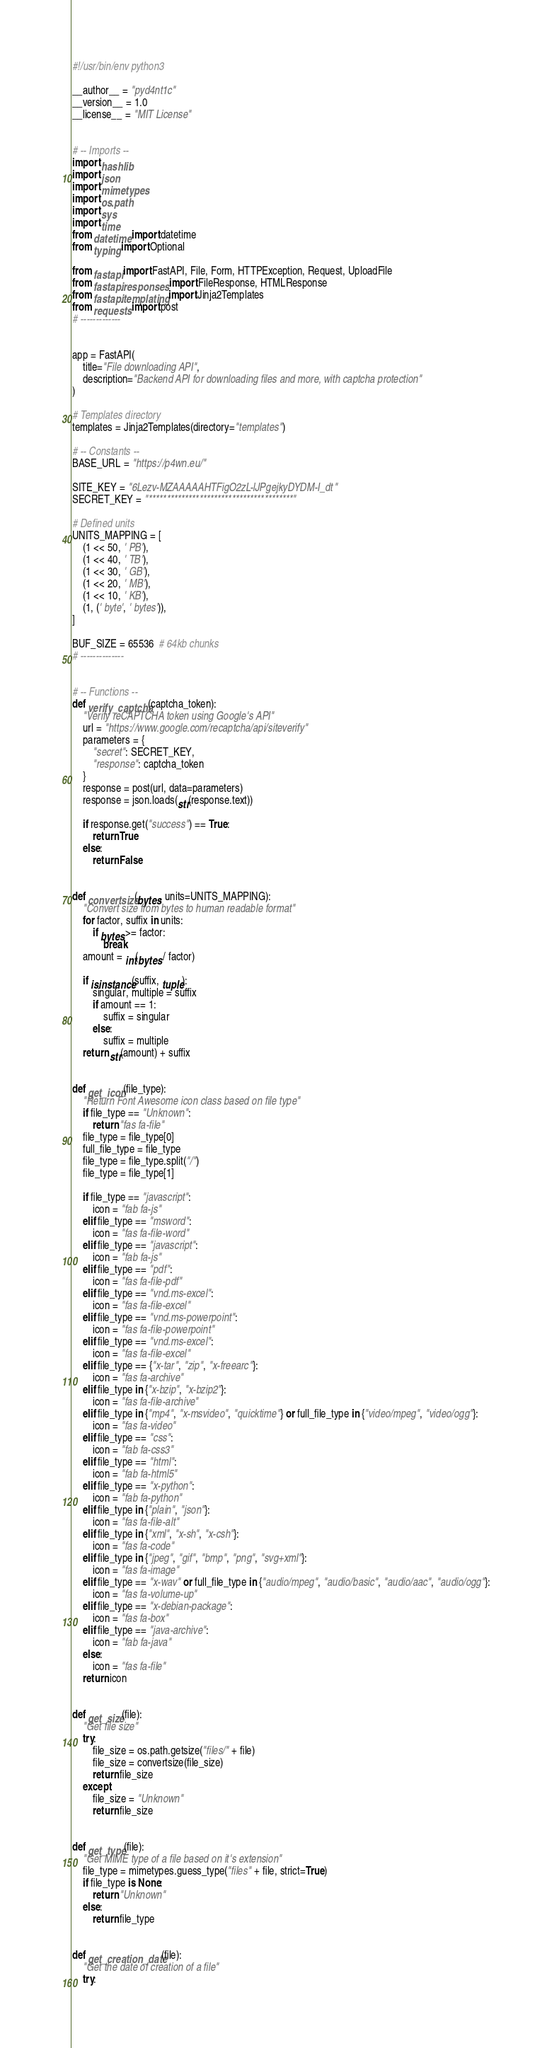<code> <loc_0><loc_0><loc_500><loc_500><_Python_>#!/usr/bin/env python3

__author__ = "pyd4nt1c"
__version__ = 1.0
__license__ = "MIT License"


# -- Imports --
import hashlib
import json
import mimetypes
import os.path
import sys
import time
from datetime import datetime
from typing import Optional

from fastapi import FastAPI, File, Form, HTTPException, Request, UploadFile
from fastapi.responses import FileResponse, HTMLResponse
from fastapi.templating import Jinja2Templates
from requests import post
# -------------


app = FastAPI(
    title="File downloading API",
    description="Backend API for downloading files and more, with captcha protection"
)

# Templates directory
templates = Jinja2Templates(directory="templates")

# -- Constants --
BASE_URL = "https://p4wn.eu/"

SITE_KEY = "6Lezv-MZAAAAAHTFigO2zL-lJPgejkyDYDM-I_dt"
SECRET_KEY = "****************************************"

# Defined units
UNITS_MAPPING = [
    (1 << 50, ' PB'),
    (1 << 40, ' TB'),
    (1 << 30, ' GB'),
    (1 << 20, ' MB'),
    (1 << 10, ' KB'),
    (1, (' byte', ' bytes')),
]

BUF_SIZE = 65536  # 64kb chunks
# --------------


# -- Functions --
def verify_captcha(captcha_token):
    "Verify reCAPTCHA token using Google's API"
    url = "https://www.google.com/recaptcha/api/siteverify"
    parameters = {
        "secret": SECRET_KEY,
        "response": captcha_token
    }
    response = post(url, data=parameters)
    response = json.loads(str(response.text))

    if response.get("success") == True:
        return True
    else:
        return False


def convertsize(bytes, units=UNITS_MAPPING):
    "Convert size from bytes to human readable format"
    for factor, suffix in units:
        if bytes >= factor:
            break
    amount = int(bytes / factor)

    if isinstance(suffix, tuple):
        singular, multiple = suffix
        if amount == 1:
            suffix = singular
        else:
            suffix = multiple
    return str(amount) + suffix


def get_icon(file_type):
    "Return Font Awesome icon class based on file type"
    if file_type == "Unknown":
        return "fas fa-file"
    file_type = file_type[0]
    full_file_type = file_type
    file_type = file_type.split("/")
    file_type = file_type[1]

    if file_type == "javascript":
        icon = "fab fa-js"
    elif file_type == "msword":
        icon = "fas fa-file-word"
    elif file_type == "javascript":
        icon = "fab fa-js"
    elif file_type == "pdf":
        icon = "fas fa-file-pdf"
    elif file_type == "vnd.ms-excel":
        icon = "fas fa-file-excel"
    elif file_type == "vnd.ms-powerpoint":
        icon = "fas fa-file-powerpoint"
    elif file_type == "vnd.ms-excel":
        icon = "fas fa-file-excel"
    elif file_type == {"x-tar", "zip", "x-freearc"}:
        icon = "fas fa-archive"
    elif file_type in {"x-bzip", "x-bzip2"}:
        icon = "fas fa-file-archive"
    elif file_type in {"mp4", "x-msvideo", "quicktime"} or full_file_type in {"video/mpeg", "video/ogg"}:
        icon = "fas fa-video"
    elif file_type == "css":
        icon = "fab fa-css3"
    elif file_type == "html":
        icon = "fab fa-html5"
    elif file_type == "x-python":
        icon = "fab fa-python"
    elif file_type in {"plain", "json"}:
        icon = "fas fa-file-alt"
    elif file_type in {"xml", "x-sh", "x-csh"}:
        icon = "fas fa-code"
    elif file_type in {"jpeg", "gif", "bmp", "png", "svg+xml"}:
        icon = "fas fa-image"
    elif file_type == "x-wav" or full_file_type in {"audio/mpeg", "audio/basic", "audio/aac", "audio/ogg"}:
        icon = "fas fa-volume-up"
    elif file_type == "x-debian-package":
        icon = "fas fa-box"
    elif file_type == "java-archive":
        icon = "fab fa-java"
    else:
        icon = "fas fa-file"
    return icon


def get_size(file):
    "Get file size"
    try:
        file_size = os.path.getsize("files/" + file)
        file_size = convertsize(file_size)
        return file_size
    except:
        file_size = "Unknown"
        return file_size


def get_type(file):
    "Get MIME type of a file based on it's extension"
    file_type = mimetypes.guess_type("files" + file, strict=True)
    if file_type is None:
        return "Unknown"
    else:
        return file_type


def get_creation_date(file):
    "Get the date of creation of a file"
    try:</code> 